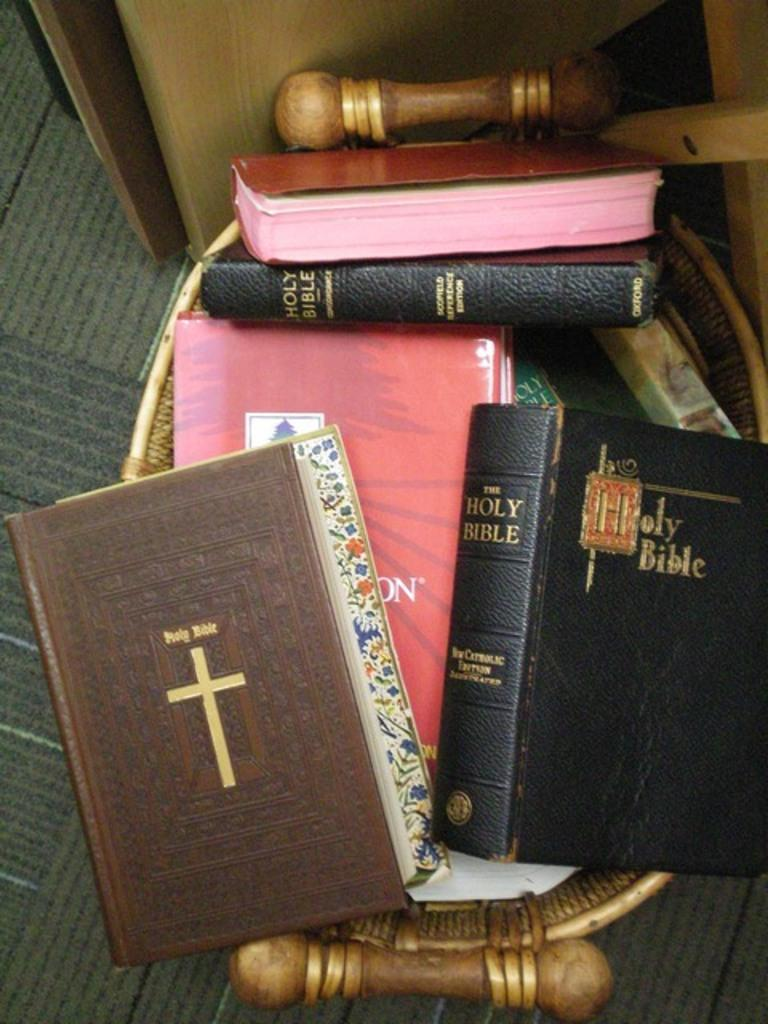What objects can be seen in the image? There are books in the image. Where are the books placed? The books are kept on an object. What type of flooring is visible in the image? There is a carpet on the floor in the image. How many shoes are visible in the image? There are no shoes visible in the image. Are there any snails crawling on the carpet in the image? There are no snails present in the image. 